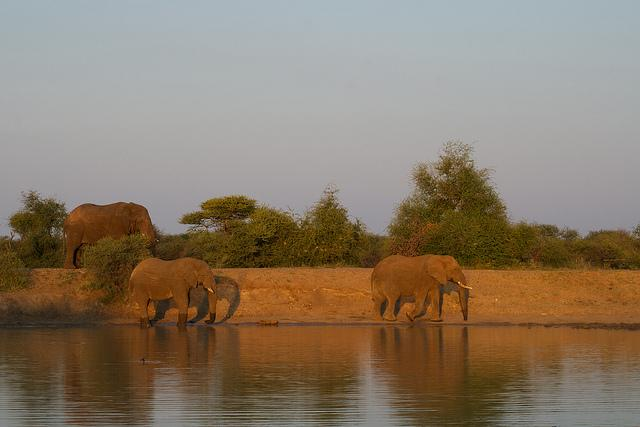What direction are the elephants facing? right 